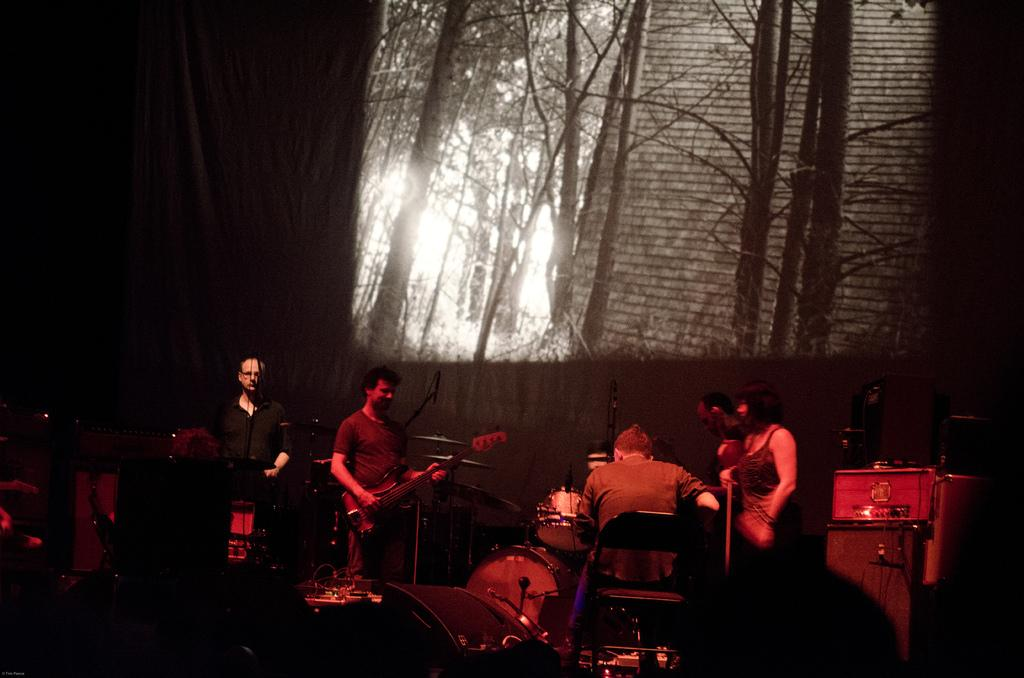What are the people in the image doing? The people in the image are playing musical instruments. What else can be seen in the image besides the people? There are devices visible in the image, and there is a screen present. How would you describe the lighting in the image? The background of the image is dark. How many sisters are visible in the image? There are no sisters present in the image. What type of zinc object can be seen in the image? There is no zinc object present in the image. 